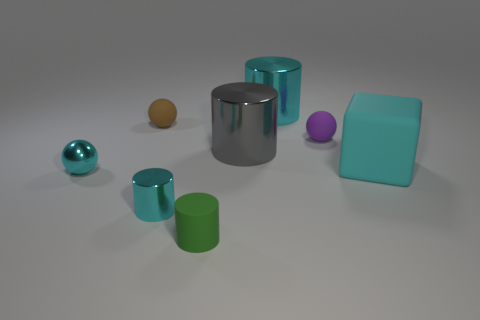Subtract all brown matte spheres. How many spheres are left? 2 Add 1 large cyan metal objects. How many objects exist? 9 Add 3 green things. How many green things exist? 4 Subtract all cyan spheres. How many spheres are left? 2 Subtract 0 red cylinders. How many objects are left? 8 Subtract all cubes. How many objects are left? 7 Subtract 1 blocks. How many blocks are left? 0 Subtract all yellow cylinders. Subtract all blue blocks. How many cylinders are left? 4 Subtract all gray balls. How many cyan cylinders are left? 2 Subtract all large gray shiny objects. Subtract all cyan rubber cubes. How many objects are left? 6 